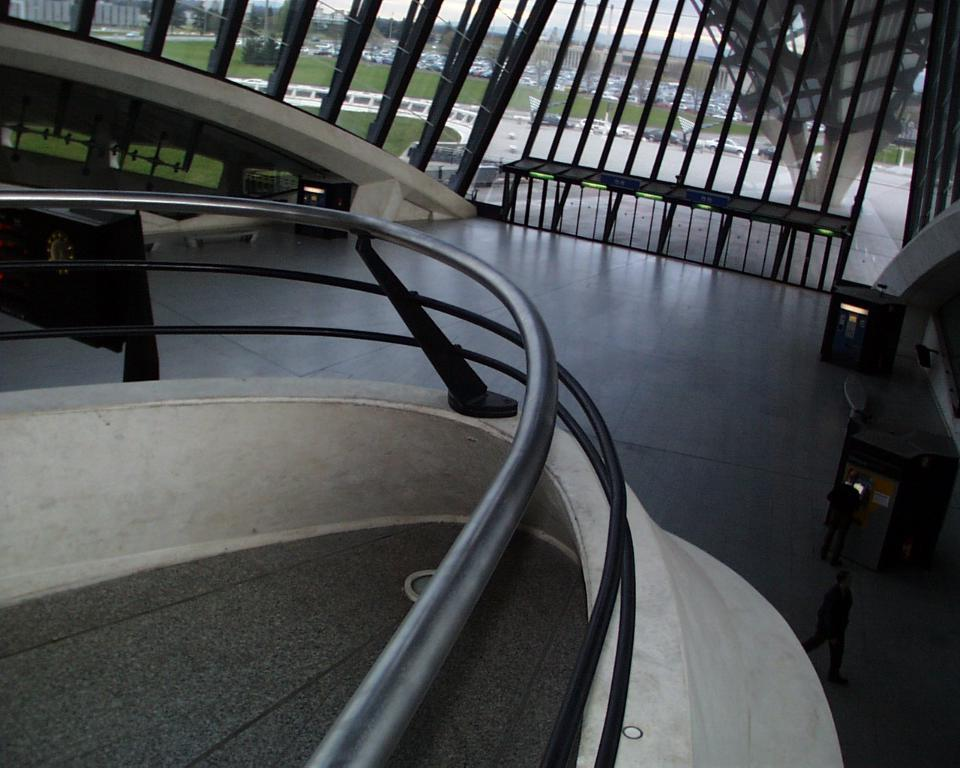What is the main subject of the image? The main subject of the image is a building. Can you describe a specific feature of the building? There is a fence in the middle of the building. What is surrounding the fence? There are grills around the fence. What type of vegetation can be seen in the image? There is grass visible in the image. Are there any other structures visible in the image? Yes, there are other buildings outside the main building. How many leaves are on the fence in the image? There are no leaves present on the fence in the image. What type of wound can be seen on the building in the image? There is no wound visible on the building in the image. 